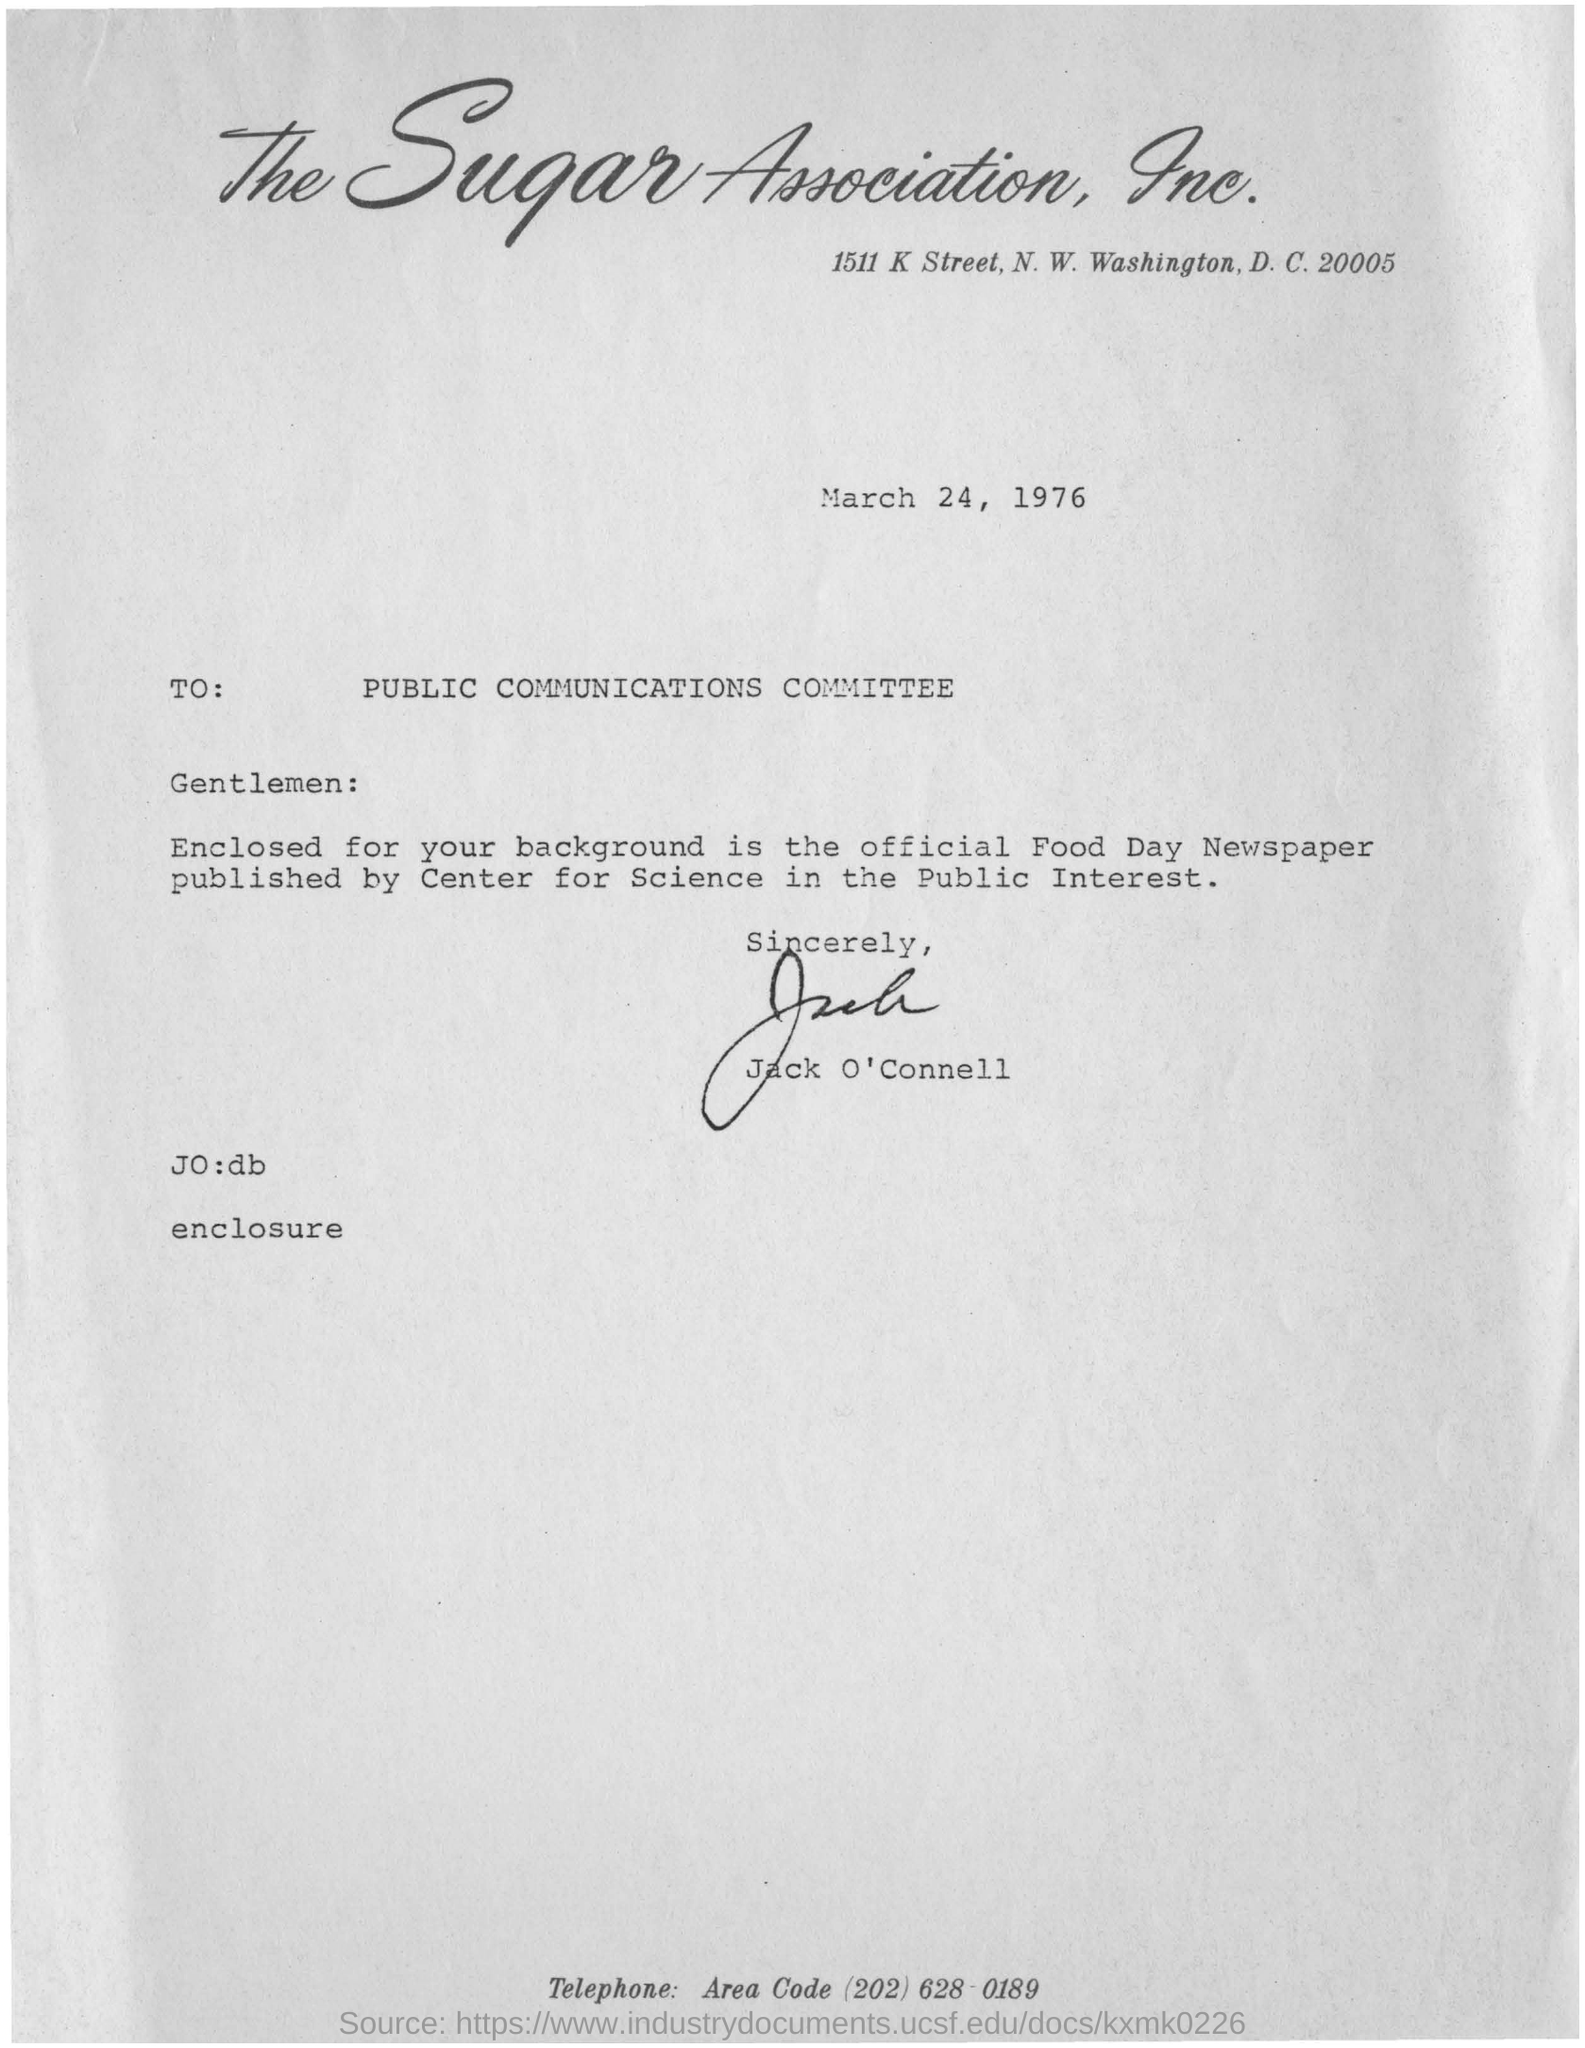Specify some key components in this picture. The letter is addressed to the Public Communications Committee. The date on the letter is March 24, 1976. The Sugar Association, Inc. is the company that the letterpad belongs to. 